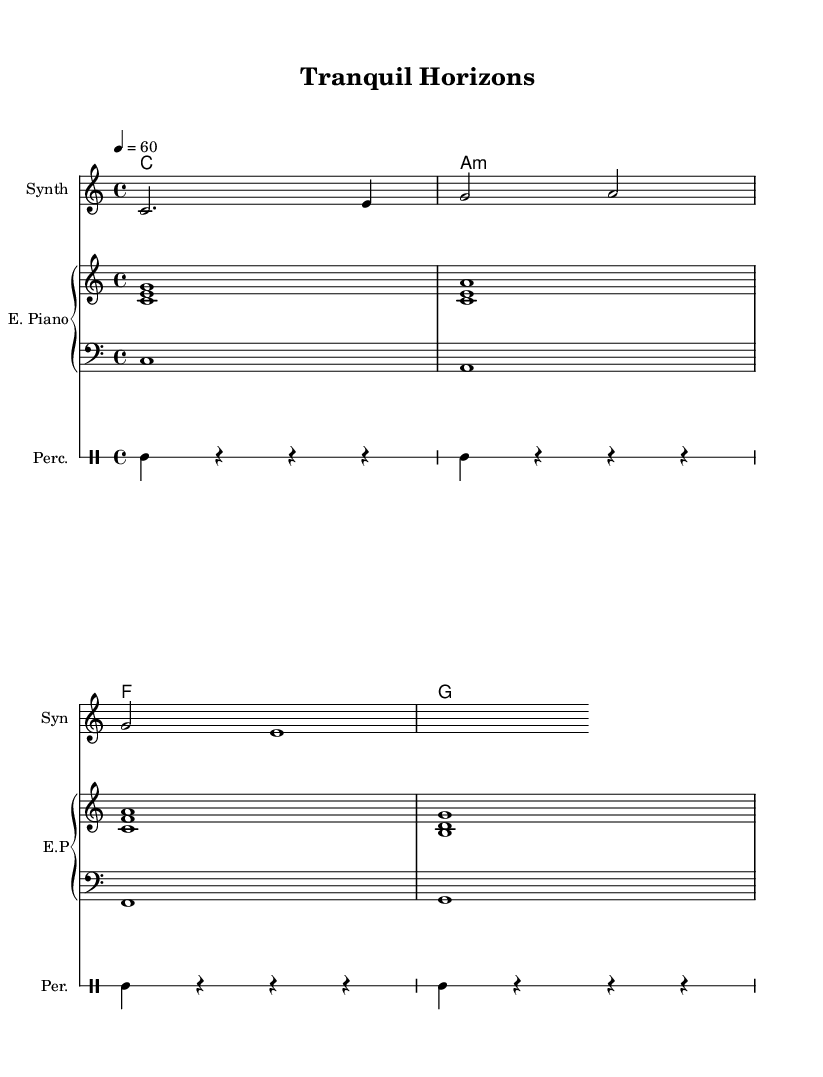What is the key signature of this music? The key signature is C major, which is indicated by no sharps or flats listed at the beginning of the staff.
Answer: C major What is the time signature of this piece? The time signature is shown at the beginning of the music, with a "4/4" marking, which indicates four beats per measure with a quarter note receiving one beat.
Answer: 4/4 What is the tempo of this composition? The tempo is indicated by the marking "4 = 60," meaning there are 60 beats per minute, with each quarter note receiving one beat.
Answer: 60 How many measures does the melody section contain? By counting the individual measures in the melody part (noted with the vertical bars), there are three complete measures in the provided melody section.
Answer: 3 What type of instrument is specified for the melody? The staff for melody indicates the instrument as "Synth," which is short for synthesizer, commonly used in ambient electronic music.
Answer: Synth What is the structure of the harmonies in this piece? The harmonies are organized in a chord mode, consisting of four distinct chords: C, A minor, F, and G, each represented as a full measure.
Answer: C, A minor, F, G How many times does the percussion repeat? The percussion section indicates a "repeat unfold 4," which specifies that the percussion motif is played four times in succession.
Answer: 4 